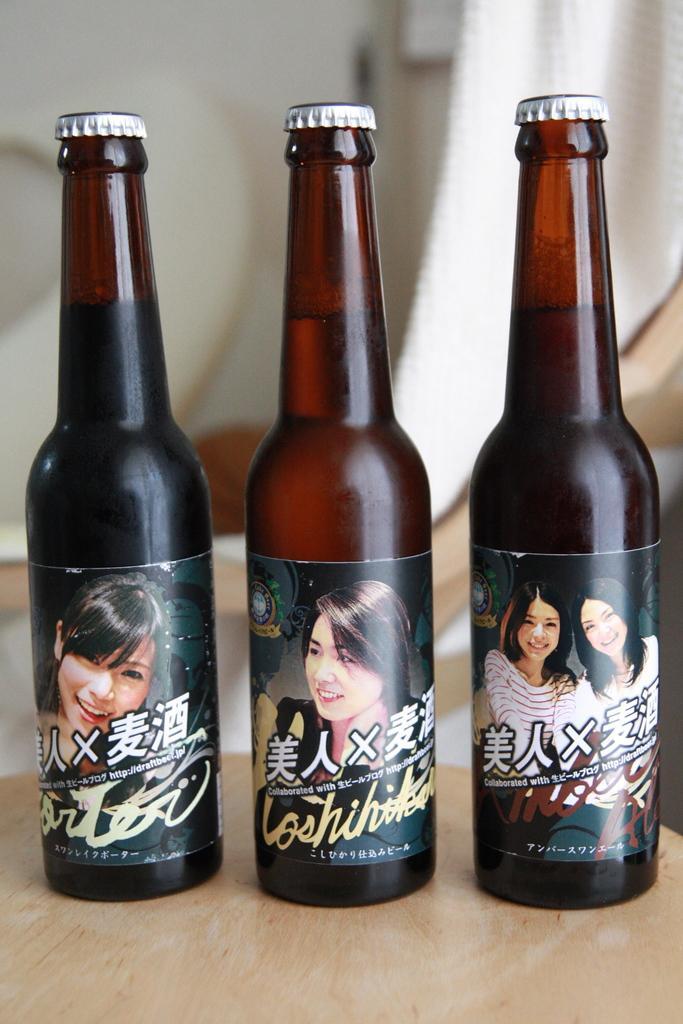How would you summarize this image in a sentence or two? In this image i can see three bottles on a table. 